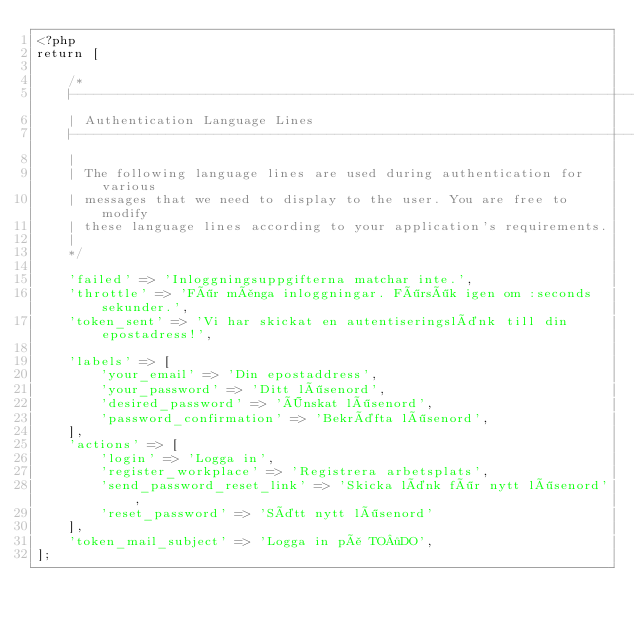<code> <loc_0><loc_0><loc_500><loc_500><_PHP_><?php
return [

    /*
    |--------------------------------------------------------------------------
    | Authentication Language Lines
    |--------------------------------------------------------------------------
    |
    | The following language lines are used during authentication for various
    | messages that we need to display to the user. You are free to modify
    | these language lines according to your application's requirements.
    |
    */

    'failed' => 'Inloggningsuppgifterna matchar inte.',
    'throttle' => 'För många inloggningar. Försök igen om :seconds sekunder.',
    'token_sent' => 'Vi har skickat en autentiseringslänk till din epostadress!',

    'labels' => [
        'your_email' => 'Din epostaddress',
        'your_password' => 'Ditt lösenord',
        'desired_password' => 'Önskat lösenord',
        'password_confirmation' => 'Bekräfta lösenord',
    ],
    'actions' => [
        'login' => 'Logga in',
        'register_workplace' => 'Registrera arbetsplats',
        'send_password_reset_link' => 'Skicka länk för nytt lösenord',
        'reset_password' => 'Sätt nytt lösenord'
    ],
    'token_mail_subject' => 'Logga in på TO·DO',
];</code> 